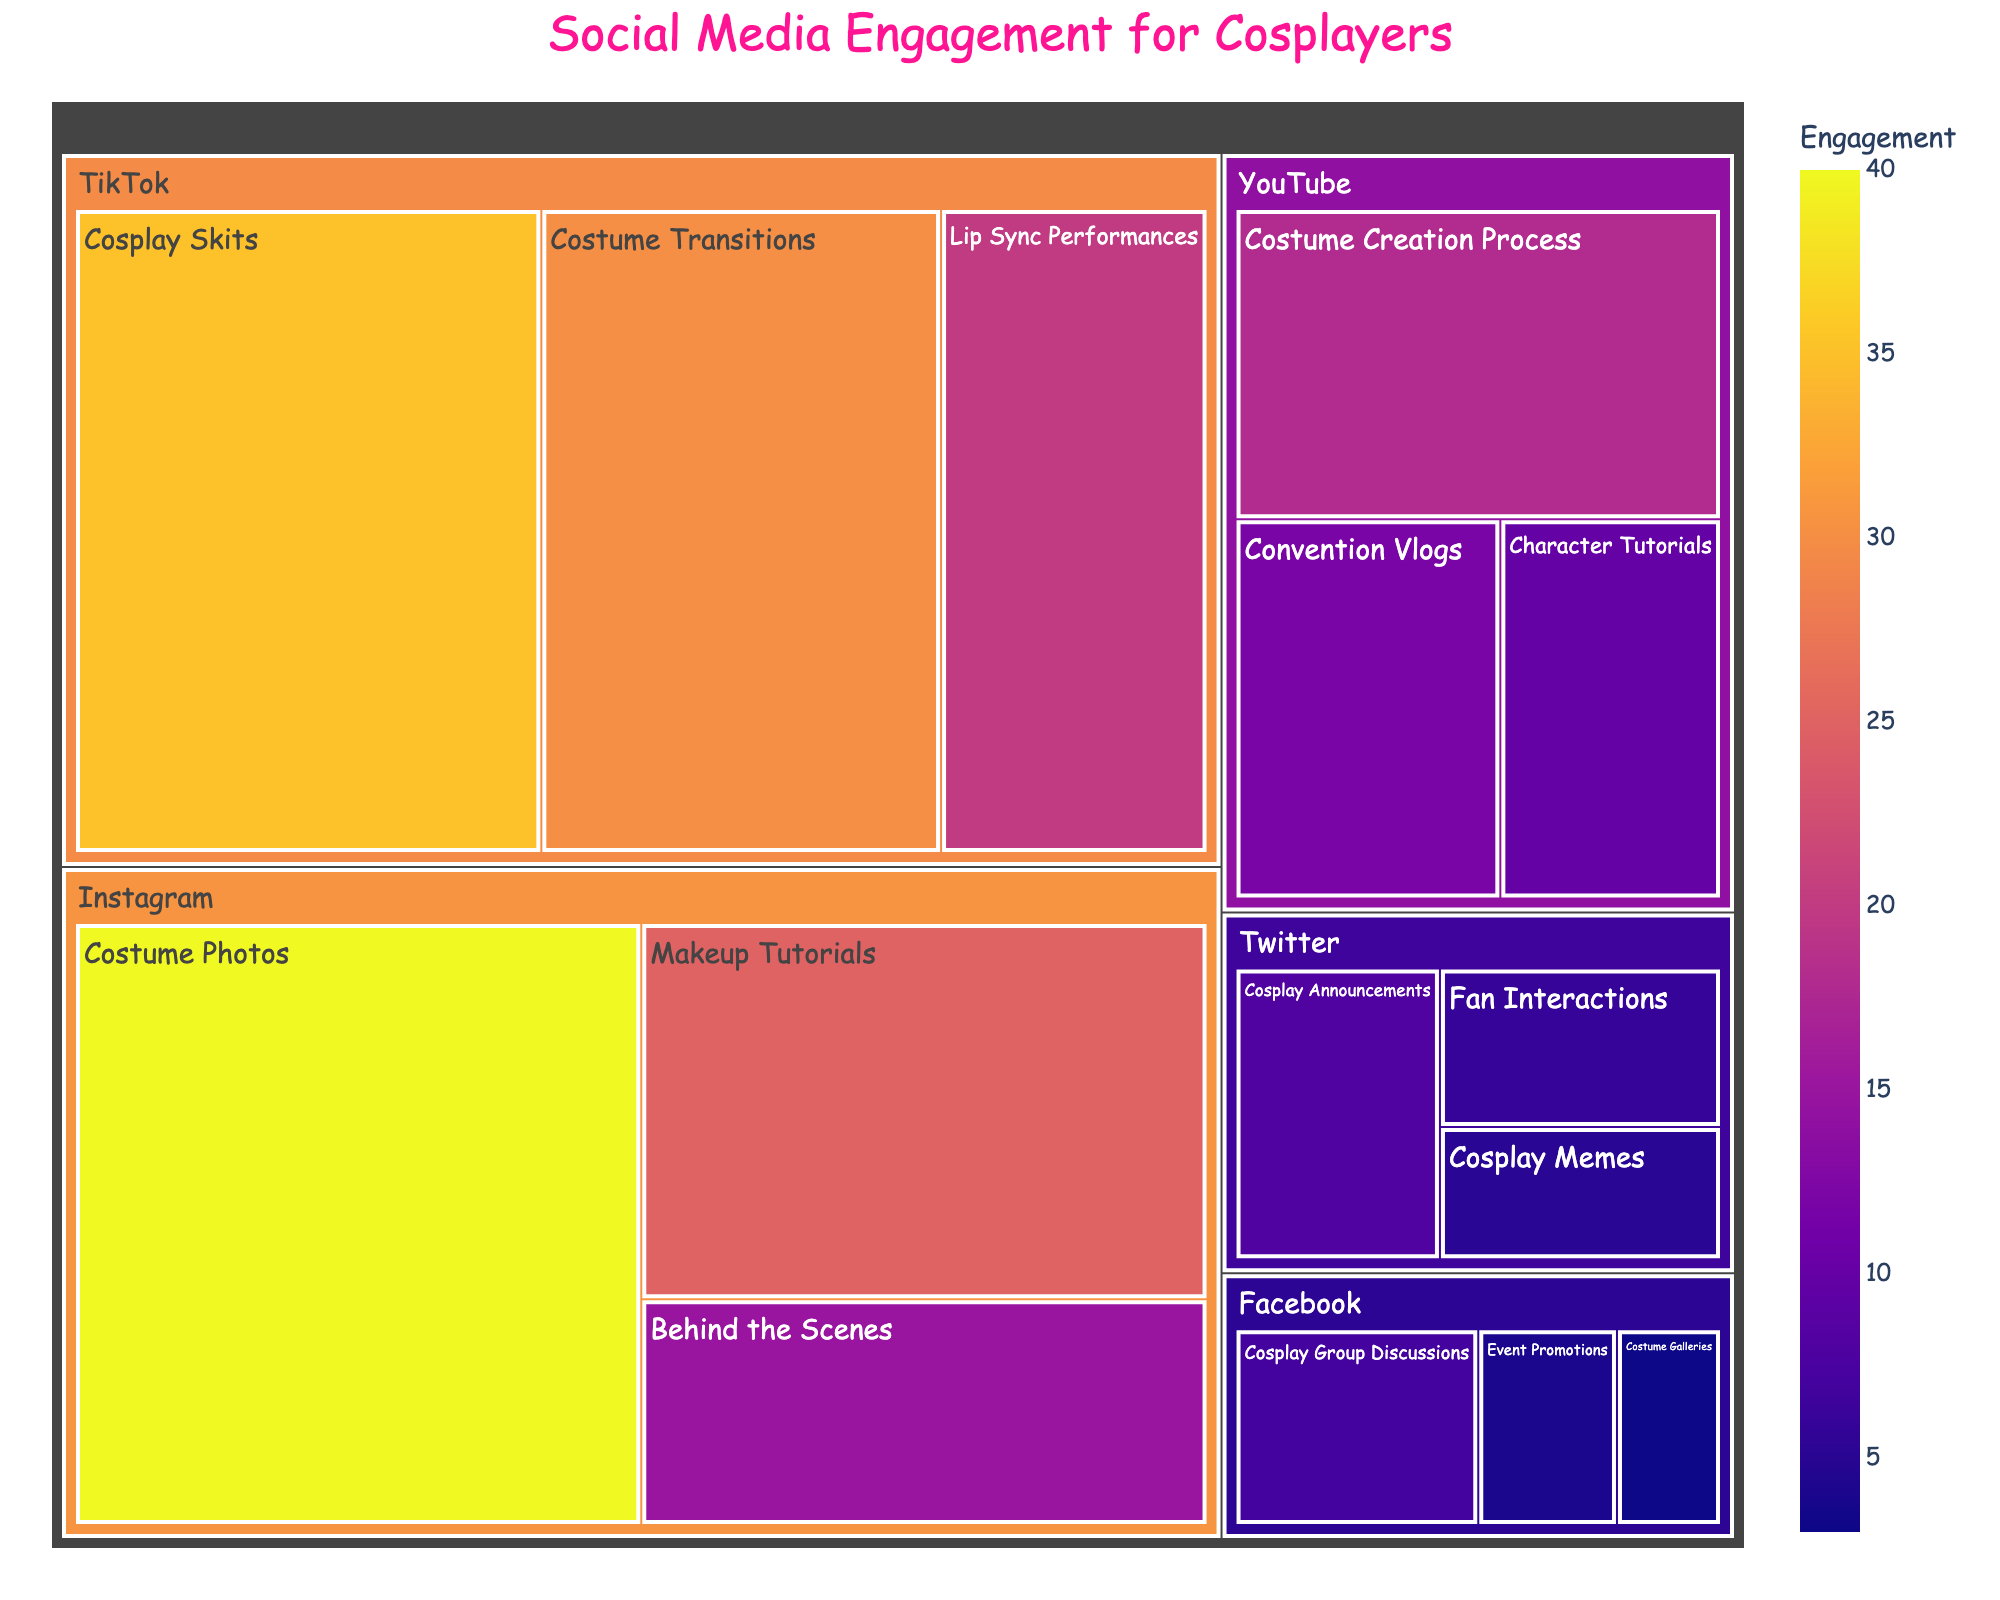What is the title of the figure? The title is found at the top of the plot, typically central aligned and more prominent compared to other text elements.
Answer: Social Media Engagement for Cosplayers Which platform has the highest overall engagement? We need to look at the largest section of the treemap which indicates higher values.
Answer: Instagram What type of content on Instagram has the highest engagement? Within the Instagram section, we look for the largest sub-section.
Answer: Costume Photos Which platform has the least engagement in total, and what content type within that platform has the highest engagement? We look for the smallest section indicating the least engagement and then identify the largest sub-section within it.
Answer: Facebook, Cosplay Group Discussions What is the total engagement across all platforms? We sum up all values in the data for each platform and content type: 40 + 25 + 15 + 35 + 30 + 20 + 18 + 12 + 10 + 8 + 6 + 5 + 7 + 4 + 3 = 238.
Answer: 238 How does engagement in Cosplay Skits on TikTok compare to engagement in Costume Creation Process on YouTube? We compare the respective values: Cosplay Skits (35) and Costume Creation Process (18).
Answer: Cosplay Skits has more engagement On which platform do Convention Vlogs have an engagement value, and how does it compare to Cosplay Announcements on Twitter? Convention Vlogs have an engagement value on YouTube. Compare the values: Convention Vlogs (12) and Cosplay Announcements (8).
Answer: YouTube, Convention Vlogs have higher engagement Which content type has the lowest engagement on Instagram? We look for the smallest sub-section under Instagram.
Answer: Behind the Scenes What is the combined engagement for Makeup Tutorials on Instagram and Character Tutorials on YouTube? We add the values of the two content types: 25 + 10 = 35.
Answer: 35 Arrange the platforms from highest to lowest total engagement. We sum up the engagement values for each platform then compare: Instagram (80), TikTok (85), YouTube (40), Twitter (19), and Facebook (14).
Answer: TikTok, Instagram, YouTube, Twitter, Facebook 